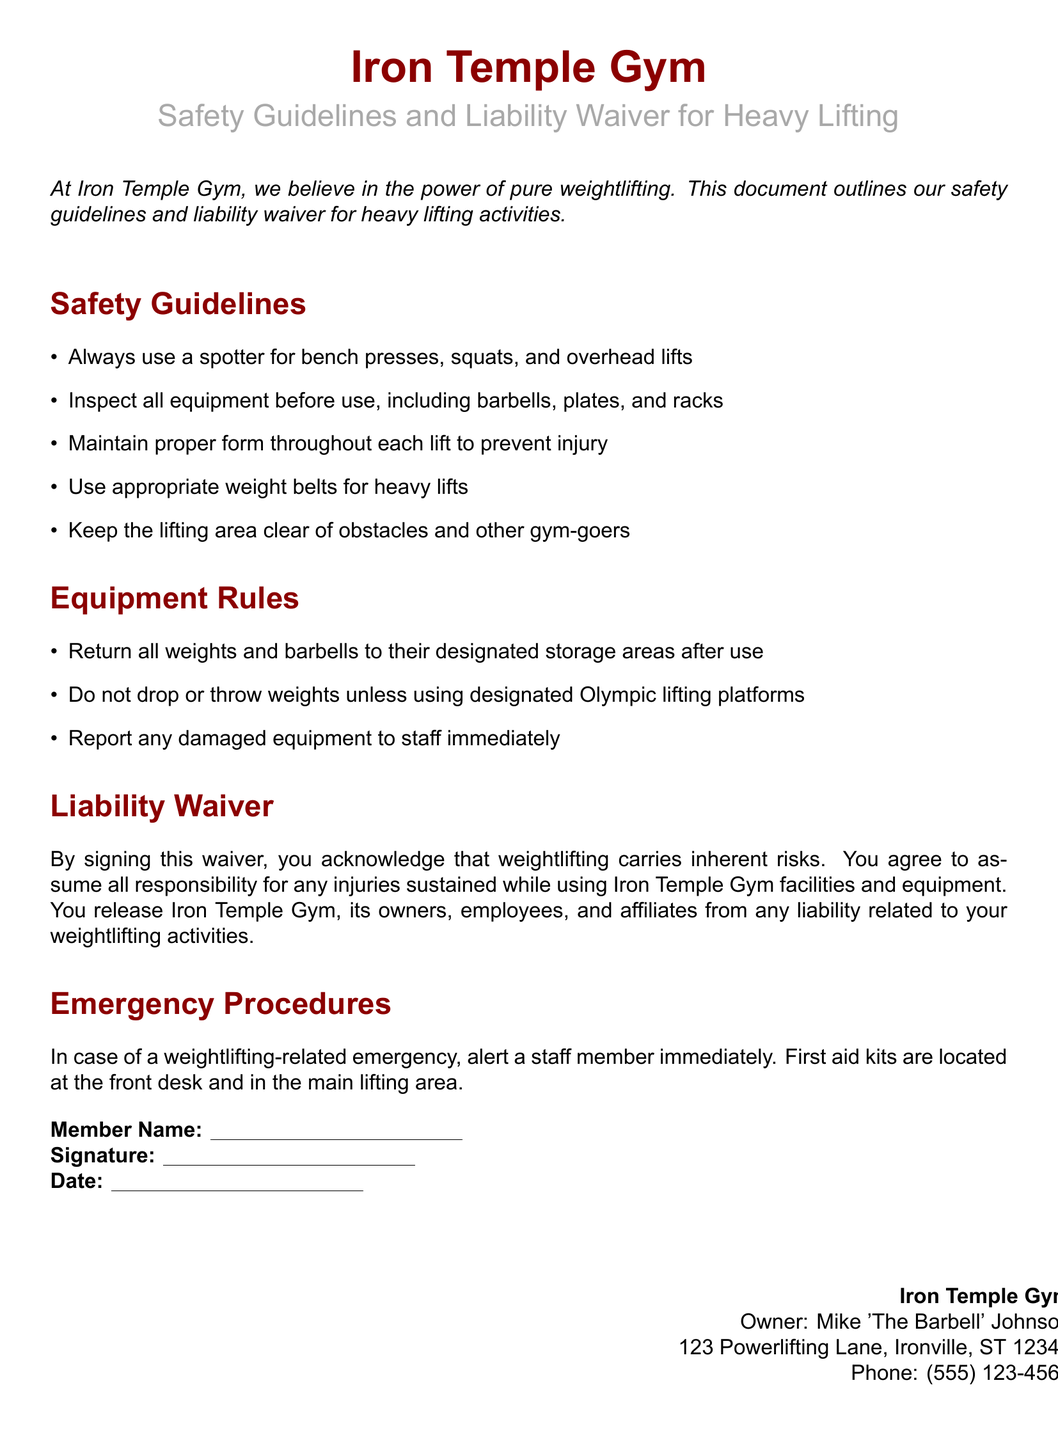What is the name of the gym? The name of the gym is stated in the title at the top of the document.
Answer: Iron Temple Gym Who is the owner of the gym? The owner's name is provided in the footer section of the document.
Answer: Mike 'The Barbell' Johnson What should be used for bench presses, squats, and overhead lifts? The guideline specifies necessary equipment for certain lifts.
Answer: Spotter Where are first aid kits located? The section on emergency procedures mentions the locations of first aid kits.
Answer: Front desk and main lifting area What must be done with weights and barbells after use? The Equipment Rules section specifies the procedure for used weights and barbells.
Answer: Return to designated storage areas What risks are acknowledged upon signing the waiver? The liability waiver states the nature of risks associated with a specific activity.
Answer: Inherent risks What color is used for the section titles? The document specifies a color scheme in the title formatting section.
Answer: Iron red What is the contact number for Iron Temple Gym? The contact information for the gym is given in the footer.
Answer: (555) 123-4567 